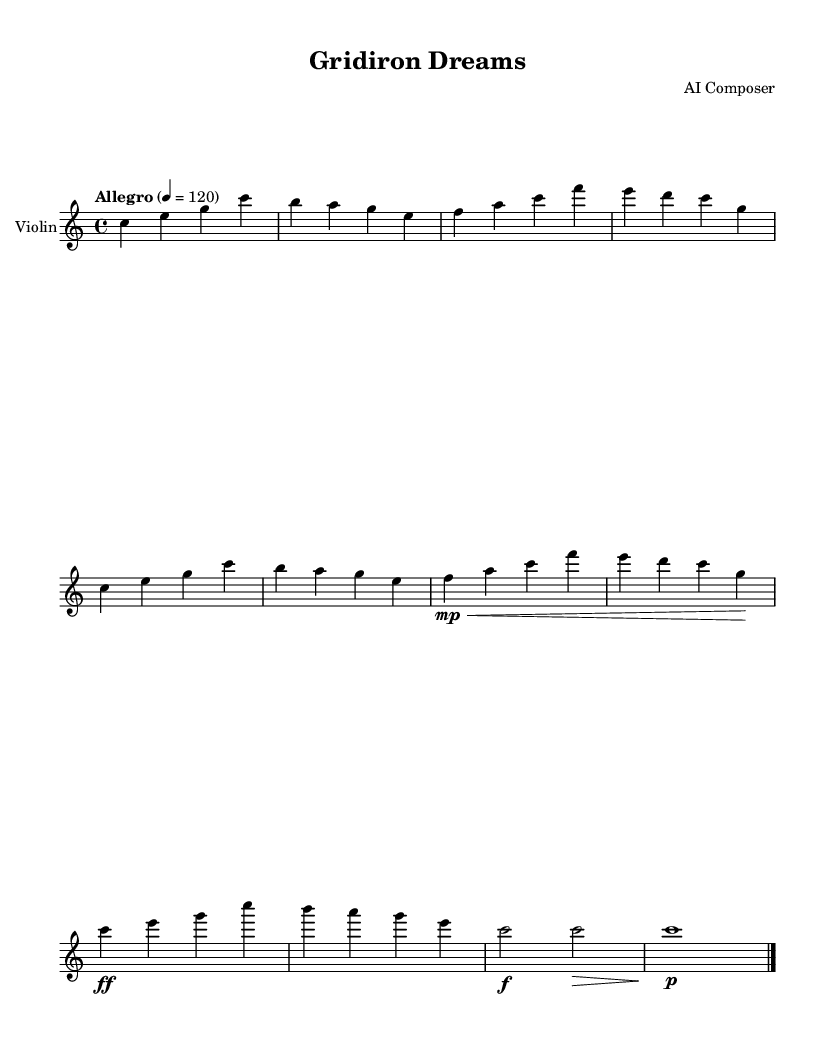What is the key signature of this music? The key signature is C major, which has no sharps or flats indicated in the sheet music. This is evident from the absence of any flat or sharp symbols next to the staff.
Answer: C major What is the time signature of this composition? The time signature is 4/4, as shown at the beginning of the sheet music. This means there are four beats in each measure and the quarter note gets one beat.
Answer: 4/4 What is the tempo marking of the piece? The tempo marking is "Allegro," which indicates a lively and fast tempo. The number 120 next to it specifies the beats per minute, meaning there are 120 quarter note beats in one minute.
Answer: Allegro 120 What dynamic marking is indicated for the triumphant climax section? The dynamic marking for the triumphant climax section is "ff," which stands for fortissimo, indicating that this part should be played very loudly. It can be found in the measure where the climax begins.
Answer: ff Identify the type of thematic material presented in the main themes. The main themes A and B both consist of melodic material that conveys an uplifting and triumphant character, typical of orchestral music in the Romantic style, which often celebrates personal achievement. This is seen in the uplifting progression of notes.
Answer: Uplifting thematic material What is the note value of the last note in the piece? The last note in the piece is a whole note (notated as "c1"), which is sustained for four beats in this 4/4 time signature. This signifies a strong conclusion to the musical statement.
Answer: whole note 